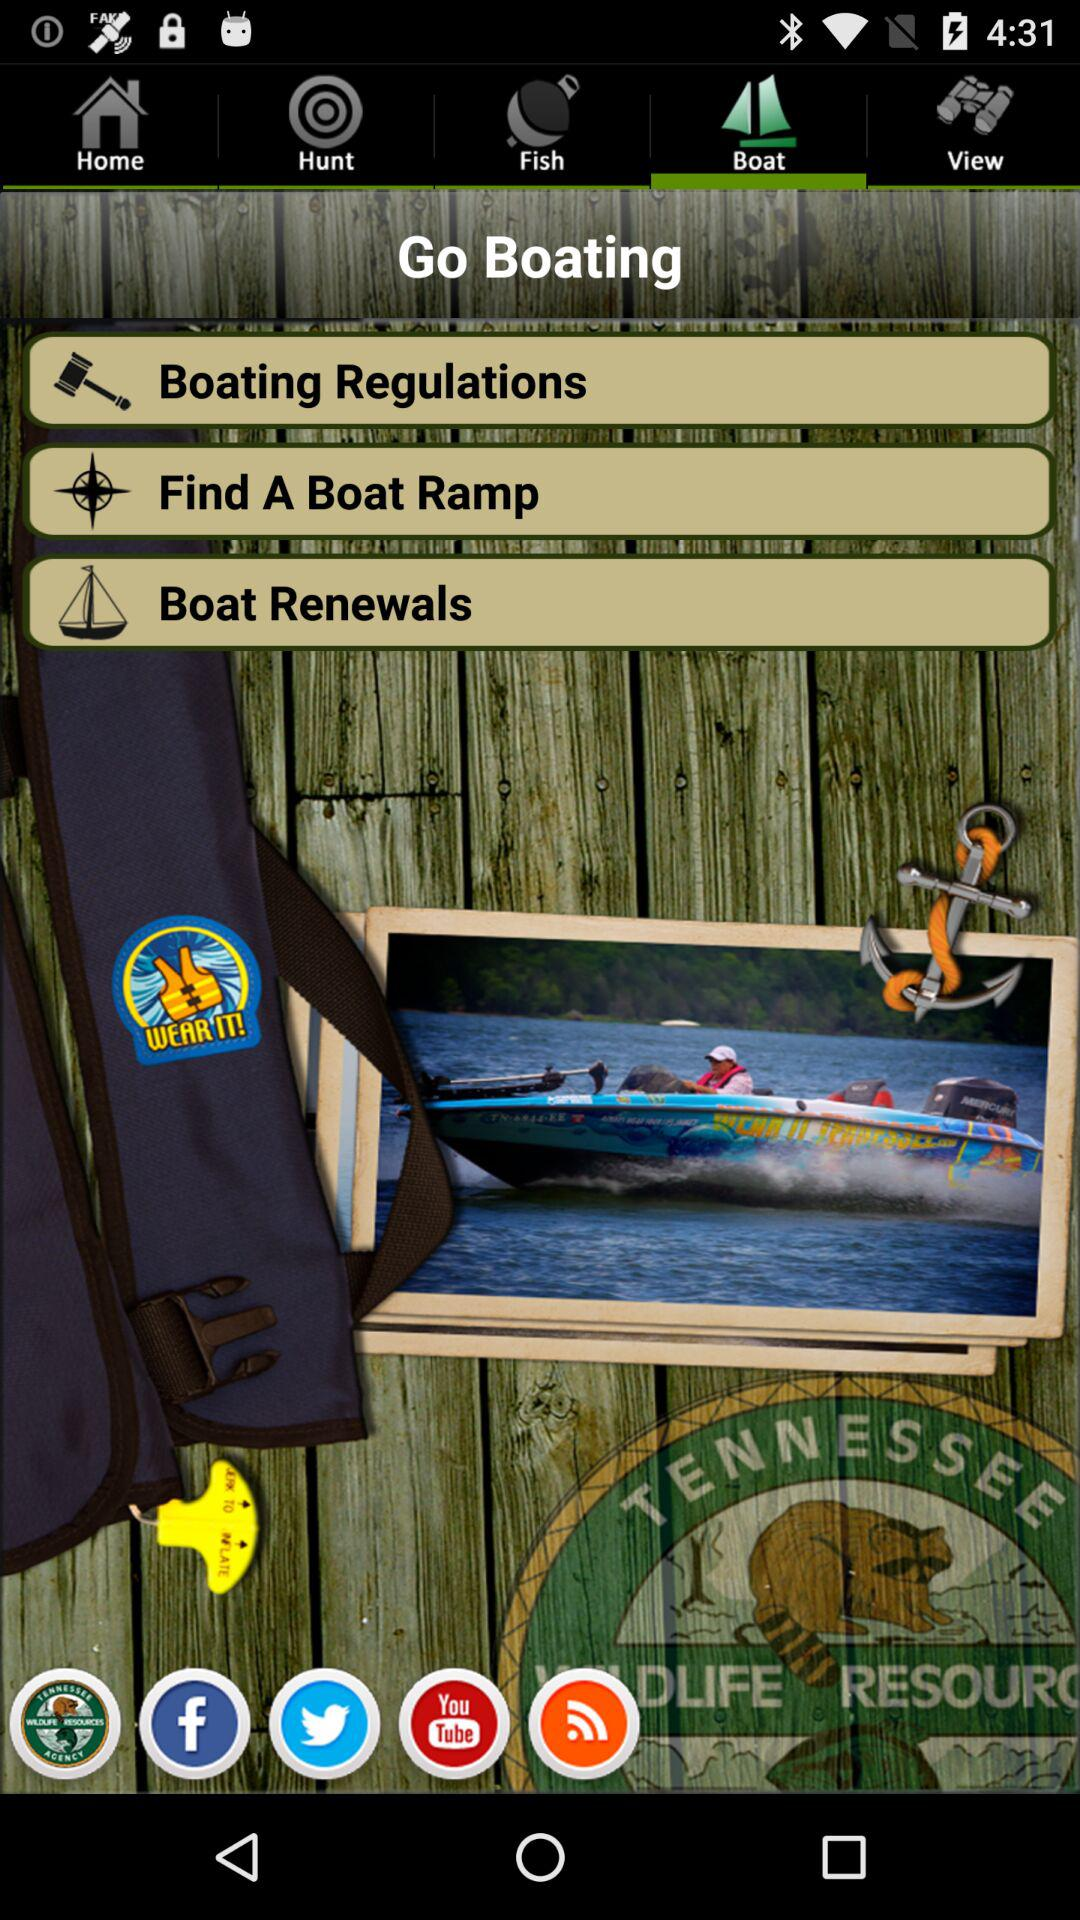How many items are in "Hunt"?
When the provided information is insufficient, respond with <no answer>. <no answer> 